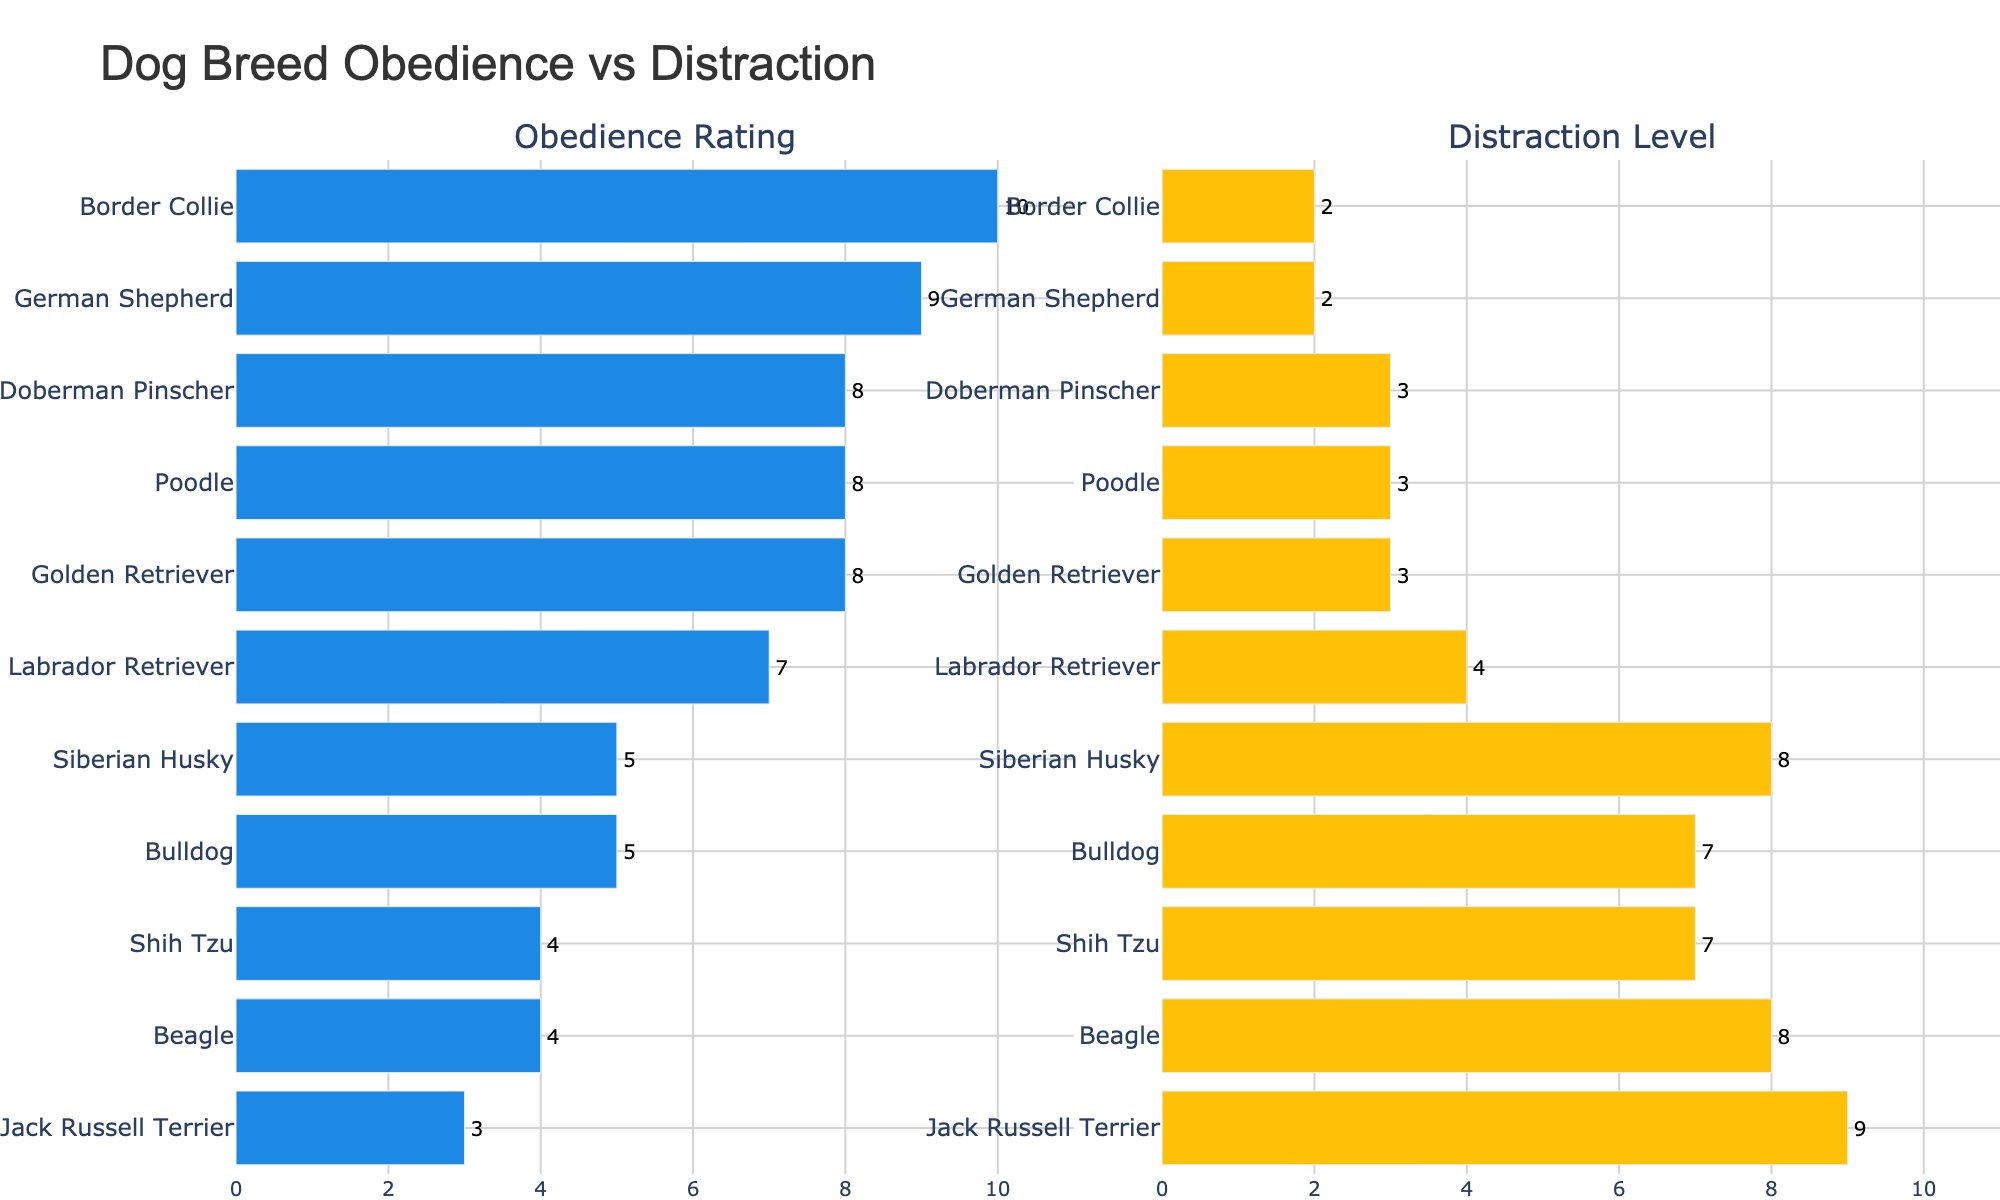Which dog breed has the highest obedience rating? Look for the breed with the tallest bar in the "Obedience Rating" section. Border Collie has the highest obedience rating with a value of 10.
Answer: Border Collie Which breed has the highest distraction level? Find the breed with the longest bar in the "Distraction Level" section. Jack Russell Terrier has the highest distraction level with a value of 9.
Answer: Jack Russell Terrier What is the total of the obedience ratings for Golden Retriever, Poodle, and Doberman Pinscher? Sum up the obedience ratings of Golden Retriever (8), Poodle (8), and Doberman Pinscher (8). 8 + 8 + 8 = 24
Answer: 24 Which breeds have a distraction level greater than 7? Check the "Distraction Level" section and find bars that extend beyond the 7 mark. Jack Russell Terrier, Beagle, Siberian Husky, Bulldog, and Shih Tzu all have distraction levels greater than 7.
Answer: Jack Russell Terrier, Beagle, Siberian Husky, Bulldog, Shih Tzu Compare the obedience rating of Jack Russell Terrier and Beagle. Which breed has a higher rating? Look at the bars in the "Obedience Rating" section for both breeds. Beagle has an obedience rating of 4, which is higher than Jack Russell Terrier's rating of 3.
Answer: Beagle How many breeds have an obedience rating below 6? Count the bars in the "Obedience Rating" section that are below the 6 mark. The breeds are Jack Russell Terrier, Beagle, Bulldog, and Shih Tzu, making a total of 4 breeds.
Answer: 4 Compare the Bulldog's obedience rating and distraction level. Which is higher? Look at both sections for the Bulldog's ratings. Bulldog has an obedience rating of 5 and a distraction level of 7, so the distraction level is higher.
Answer: Distraction level What is the difference in distraction levels between German Shepherd and Labrador Retriever? Subtract the distraction level of German Shepherd (2) from that of Labrador Retriever (4). 4 - 2 = 2
Answer: 2 Which breed has a similar distraction level to the Golden Retriever? In the "Distraction Level" section, identify bars that are near 3, the value for Golden Retriever. Poodle and Doberman Pinscher both have a distraction level of 3, similar to Golden Retriever.
Answer: Poodle, Doberman Pinscher What is the median obedience rating for the breeds listed? Arrange the obedience ratings in ascending order (3, 4, 4, 5, 5, 7, 8, 8, 8, 9, 10) and find the middle number. The median obedience rating is the 6th value, which is 7.
Answer: 7 